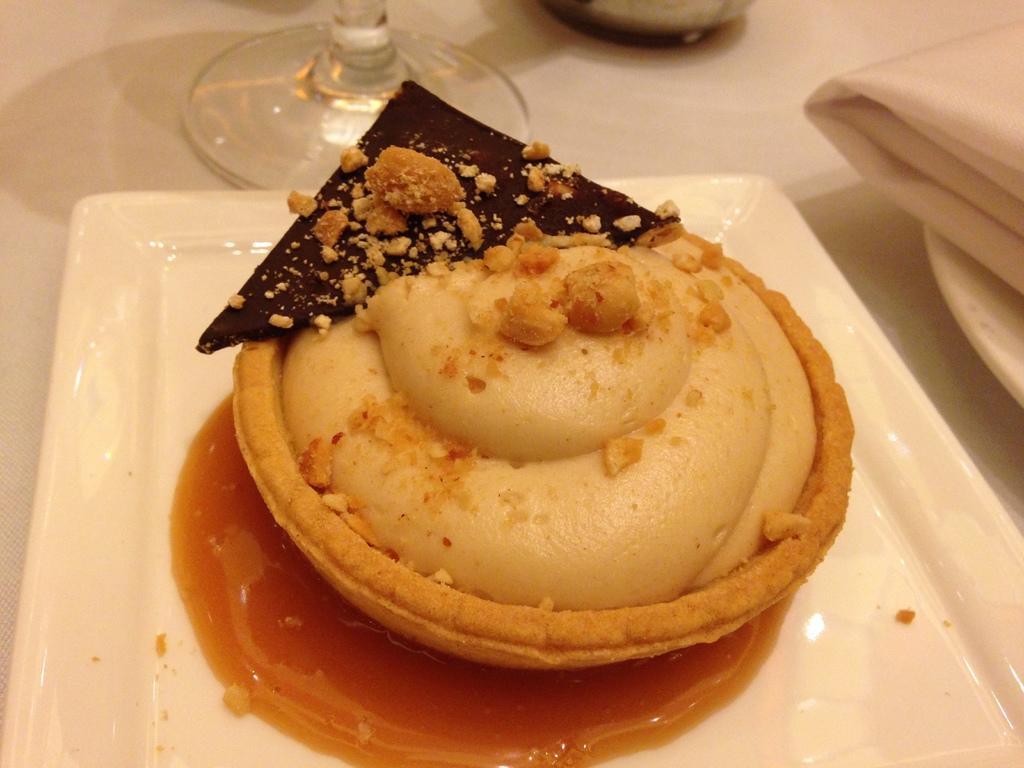In one or two sentences, can you explain what this image depicts? In this image I can see a food item on a white plate. There is a white napkin on the right and there is a wine glass at the back. 